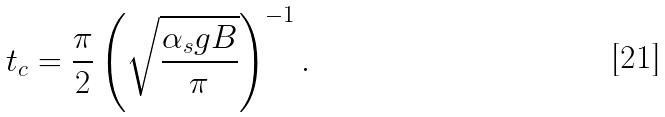<formula> <loc_0><loc_0><loc_500><loc_500>t _ { c } = \frac { \pi } { 2 } \left ( \sqrt { \frac { \alpha _ { s } g B } { \pi } } \right ) ^ { - 1 } .</formula> 